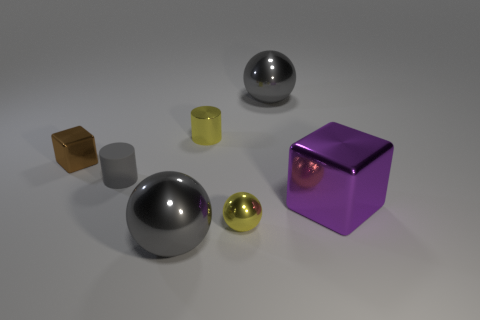There is a block that is the same size as the matte cylinder; what is its color? The block that matches the matte cylinder in size has a purple hue, reflecting a deep, vivid shade that stands out among the other objects in the scene. 